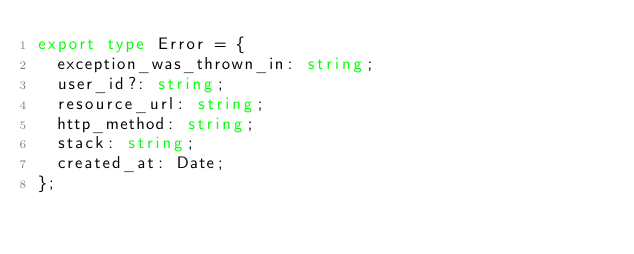Convert code to text. <code><loc_0><loc_0><loc_500><loc_500><_TypeScript_>export type Error = {
  exception_was_thrown_in: string;
  user_id?: string;
  resource_url: string;
  http_method: string;
  stack: string;
  created_at: Date;
};
</code> 